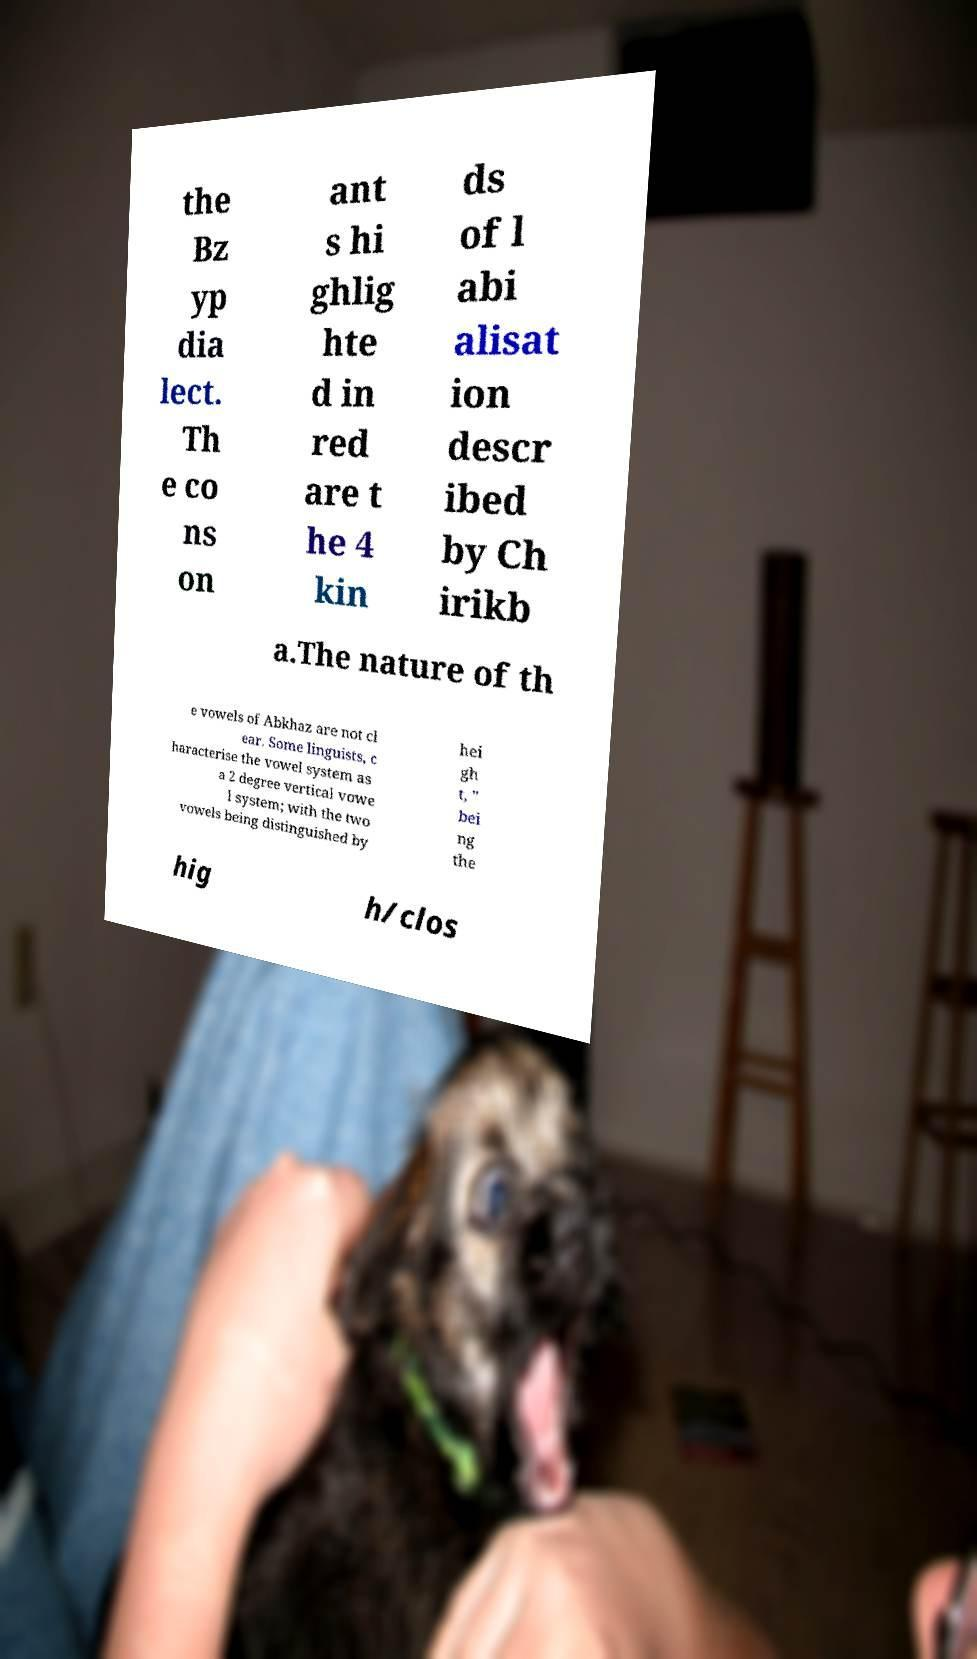What messages or text are displayed in this image? I need them in a readable, typed format. the Bz yp dia lect. Th e co ns on ant s hi ghlig hte d in red are t he 4 kin ds of l abi alisat ion descr ibed by Ch irikb a.The nature of th e vowels of Abkhaz are not cl ear. Some linguists, c haracterise the vowel system as a 2 degree vertical vowe l system; with the two vowels being distinguished by hei gh t, '' bei ng the hig h/clos 